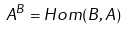Convert formula to latex. <formula><loc_0><loc_0><loc_500><loc_500>A ^ { B } = H o m ( B , A )</formula> 